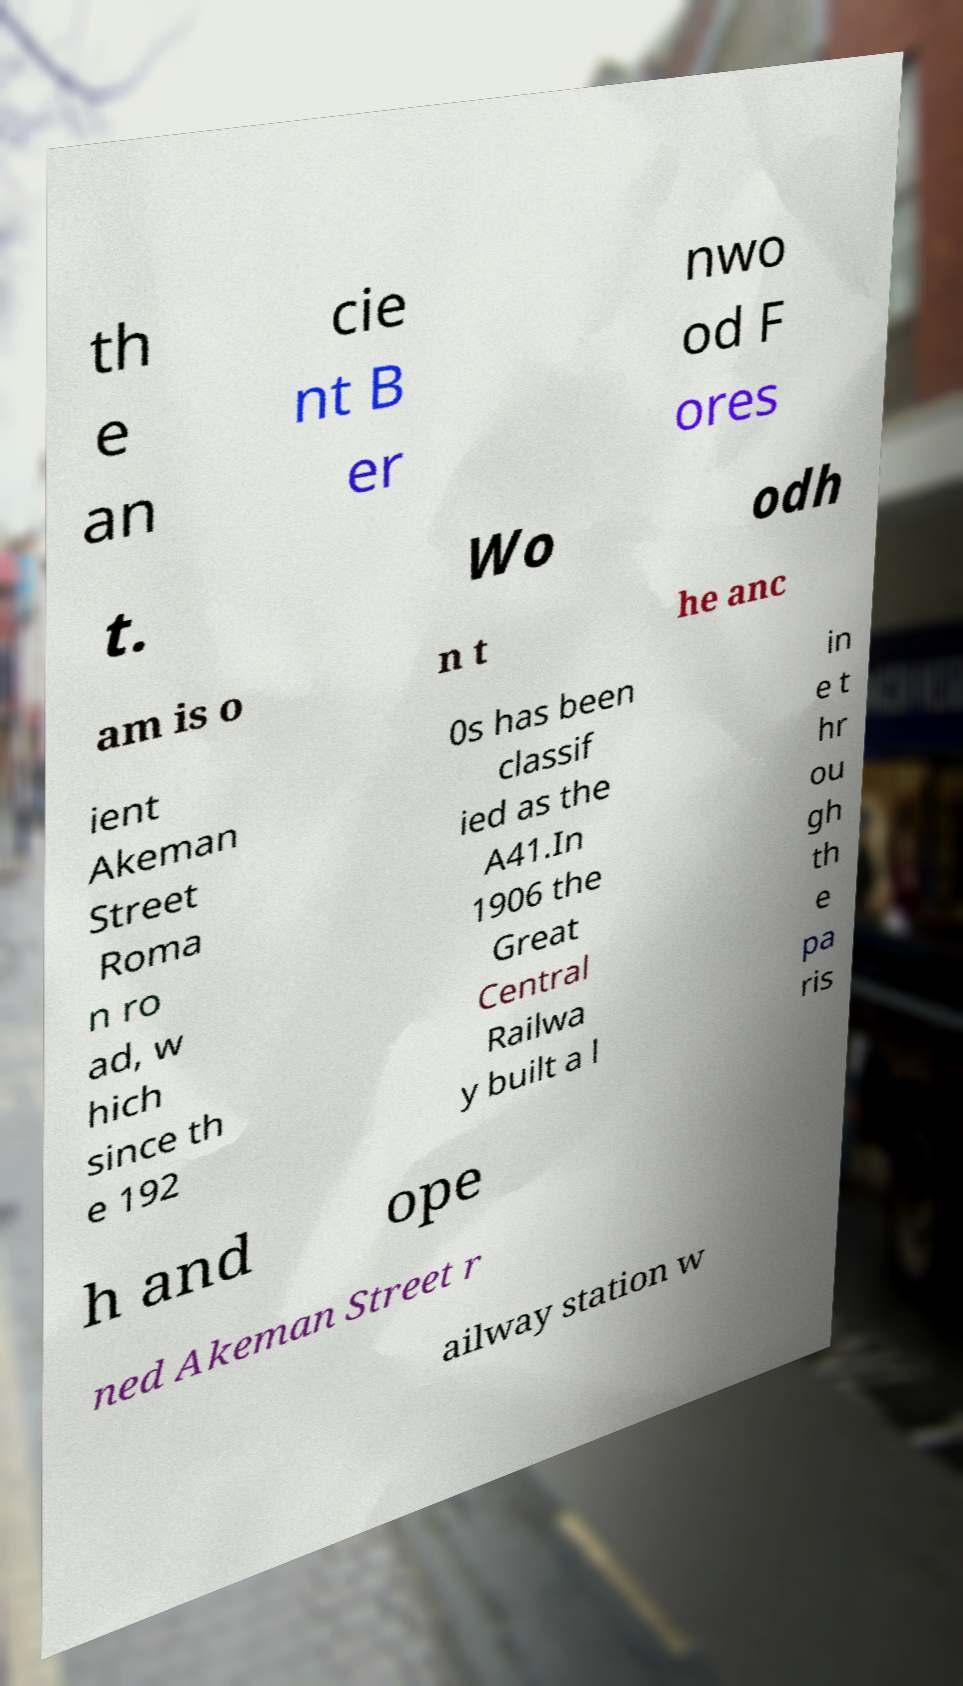Could you assist in decoding the text presented in this image and type it out clearly? th e an cie nt B er nwo od F ores t. Wo odh am is o n t he anc ient Akeman Street Roma n ro ad, w hich since th e 192 0s has been classif ied as the A41.In 1906 the Great Central Railwa y built a l in e t hr ou gh th e pa ris h and ope ned Akeman Street r ailway station w 